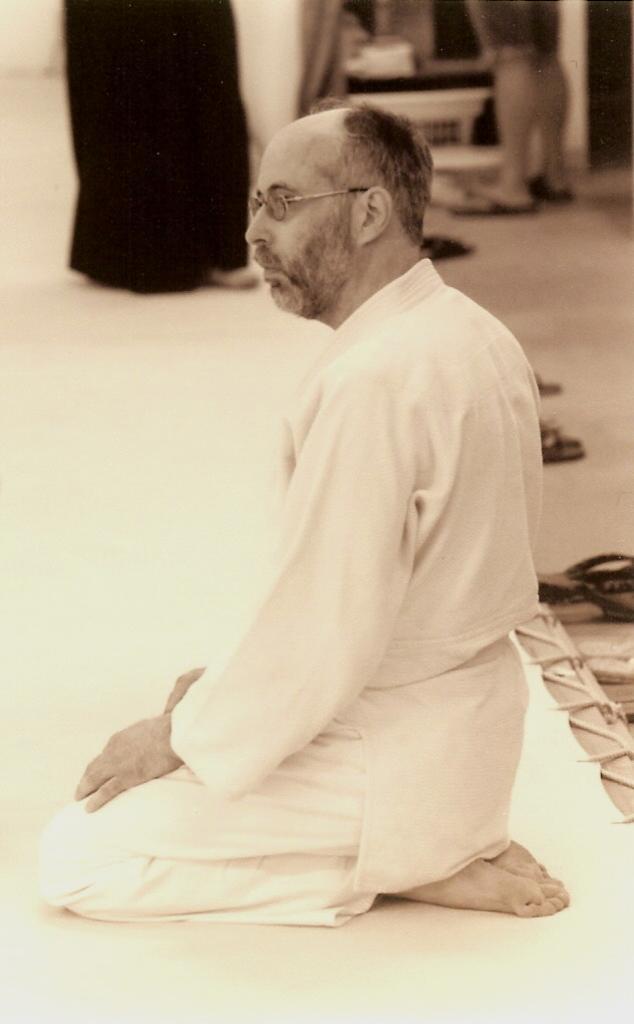Can you describe this image briefly? In this image I can see a person sitting on his knees. There are persons and there are some other objects in the background. 